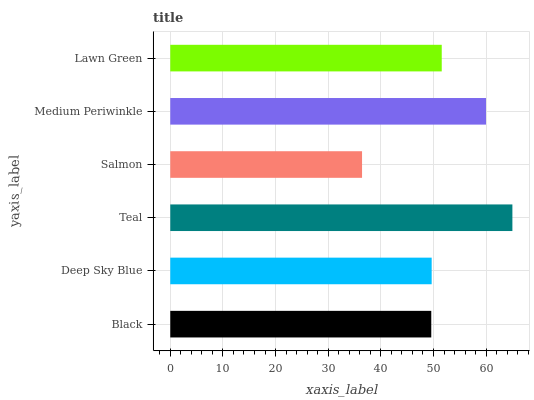Is Salmon the minimum?
Answer yes or no. Yes. Is Teal the maximum?
Answer yes or no. Yes. Is Deep Sky Blue the minimum?
Answer yes or no. No. Is Deep Sky Blue the maximum?
Answer yes or no. No. Is Deep Sky Blue greater than Black?
Answer yes or no. Yes. Is Black less than Deep Sky Blue?
Answer yes or no. Yes. Is Black greater than Deep Sky Blue?
Answer yes or no. No. Is Deep Sky Blue less than Black?
Answer yes or no. No. Is Lawn Green the high median?
Answer yes or no. Yes. Is Deep Sky Blue the low median?
Answer yes or no. Yes. Is Medium Periwinkle the high median?
Answer yes or no. No. Is Teal the low median?
Answer yes or no. No. 